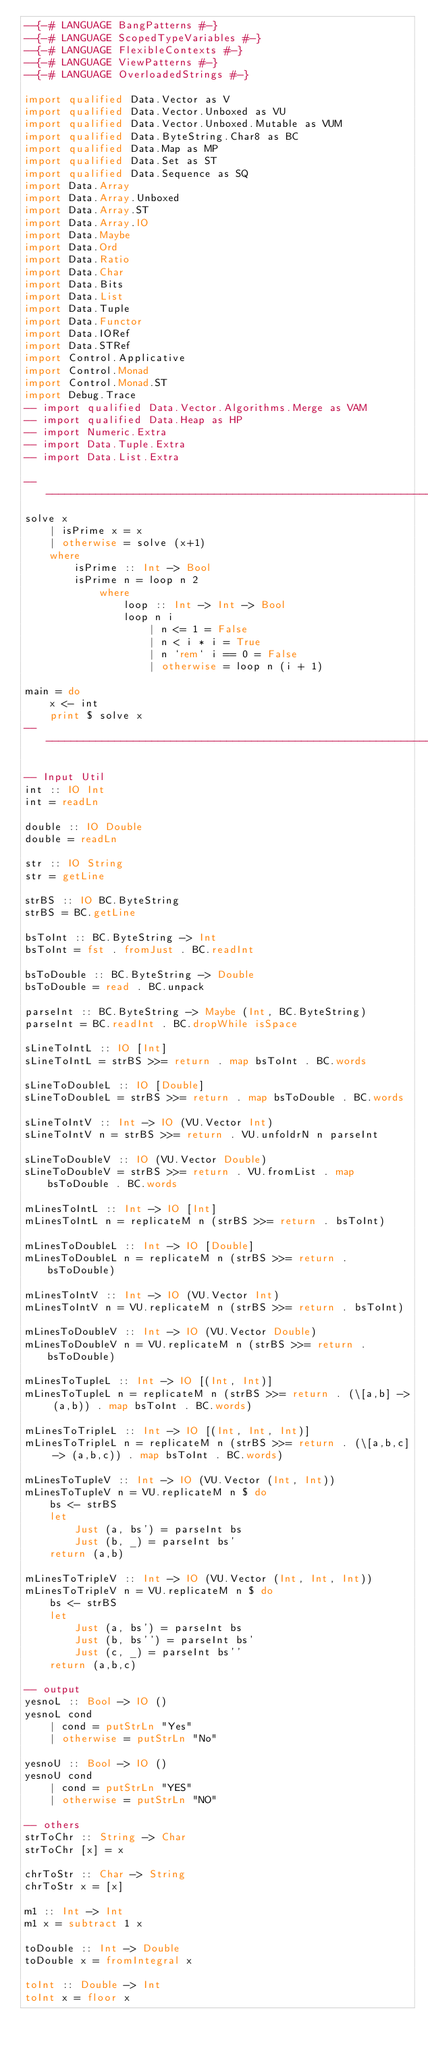<code> <loc_0><loc_0><loc_500><loc_500><_Haskell_>--{-# LANGUAGE BangPatterns #-}
--{-# LANGUAGE ScopedTypeVariables #-}
--{-# LANGUAGE FlexibleContexts #-}
--{-# LANGUAGE ViewPatterns #-}
--{-# LANGUAGE OverloadedStrings #-}

import qualified Data.Vector as V
import qualified Data.Vector.Unboxed as VU
import qualified Data.Vector.Unboxed.Mutable as VUM
import qualified Data.ByteString.Char8 as BC
import qualified Data.Map as MP
import qualified Data.Set as ST
import qualified Data.Sequence as SQ
import Data.Array
import Data.Array.Unboxed
import Data.Array.ST
import Data.Array.IO
import Data.Maybe
import Data.Ord
import Data.Ratio
import Data.Char
import Data.Bits
import Data.List
import Data.Tuple
import Data.Functor
import Data.IORef
import Data.STRef
import Control.Applicative
import Control.Monad
import Control.Monad.ST
import Debug.Trace
-- import qualified Data.Vector.Algorithms.Merge as VAM
-- import qualified Data.Heap as HP
-- import Numeric.Extra
-- import Data.Tuple.Extra
-- import Data.List.Extra

--------------------------------------------------------------------------
solve x
    | isPrime x = x
    | otherwise = solve (x+1)
    where
        isPrime :: Int -> Bool
        isPrime n = loop n 2
            where
                loop :: Int -> Int -> Bool
                loop n i
                    | n <= 1 = False
                    | n < i * i = True
                    | n `rem` i == 0 = False
                    | otherwise = loop n (i + 1)
 
main = do
    x <- int
    print $ solve x
--------------------------------------------------------------------------

-- Input Util
int :: IO Int
int = readLn 

double :: IO Double
double = readLn 

str :: IO String
str = getLine

strBS :: IO BC.ByteString
strBS = BC.getLine

bsToInt :: BC.ByteString -> Int
bsToInt = fst . fromJust . BC.readInt

bsToDouble :: BC.ByteString -> Double
bsToDouble = read . BC.unpack

parseInt :: BC.ByteString -> Maybe (Int, BC.ByteString)
parseInt = BC.readInt . BC.dropWhile isSpace

sLineToIntL :: IO [Int]
sLineToIntL = strBS >>= return . map bsToInt . BC.words

sLineToDoubleL :: IO [Double]
sLineToDoubleL = strBS >>= return . map bsToDouble . BC.words

sLineToIntV :: Int -> IO (VU.Vector Int)
sLineToIntV n = strBS >>= return . VU.unfoldrN n parseInt

sLineToDoubleV :: IO (VU.Vector Double)
sLineToDoubleV = strBS >>= return . VU.fromList . map bsToDouble . BC.words

mLinesToIntL :: Int -> IO [Int]
mLinesToIntL n = replicateM n (strBS >>= return . bsToInt)

mLinesToDoubleL :: Int -> IO [Double]
mLinesToDoubleL n = replicateM n (strBS >>= return . bsToDouble)

mLinesToIntV :: Int -> IO (VU.Vector Int)
mLinesToIntV n = VU.replicateM n (strBS >>= return . bsToInt)

mLinesToDoubleV :: Int -> IO (VU.Vector Double)
mLinesToDoubleV n = VU.replicateM n (strBS >>= return . bsToDouble)

mLinesToTupleL :: Int -> IO [(Int, Int)]
mLinesToTupleL n = replicateM n (strBS >>= return . (\[a,b] -> (a,b)) . map bsToInt . BC.words)

mLinesToTripleL :: Int -> IO [(Int, Int, Int)]
mLinesToTripleL n = replicateM n (strBS >>= return . (\[a,b,c] -> (a,b,c)) . map bsToInt . BC.words)

mLinesToTupleV :: Int -> IO (VU.Vector (Int, Int))
mLinesToTupleV n = VU.replicateM n $ do
    bs <- strBS
    let
        Just (a, bs') = parseInt bs
        Just (b, _) = parseInt bs'
    return (a,b)
    
mLinesToTripleV :: Int -> IO (VU.Vector (Int, Int, Int))
mLinesToTripleV n = VU.replicateM n $ do
    bs <- strBS
    let
        Just (a, bs') = parseInt bs
        Just (b, bs'') = parseInt bs'
        Just (c, _) = parseInt bs''
    return (a,b,c)

-- output
yesnoL :: Bool -> IO ()
yesnoL cond
    | cond = putStrLn "Yes"
    | otherwise = putStrLn "No"

yesnoU :: Bool -> IO ()
yesnoU cond
    | cond = putStrLn "YES"
    | otherwise = putStrLn "NO"

-- others
strToChr :: String -> Char
strToChr [x] = x

chrToStr :: Char -> String
chrToStr x = [x]

m1 :: Int -> Int
m1 x = subtract 1 x

toDouble :: Int -> Double
toDouble x = fromIntegral x

toInt :: Double -> Int
toInt x = floor x
</code> 